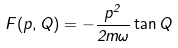Convert formula to latex. <formula><loc_0><loc_0><loc_500><loc_500>F ( p , Q ) = - \frac { p ^ { 2 } } { 2 m \omega } \tan Q</formula> 